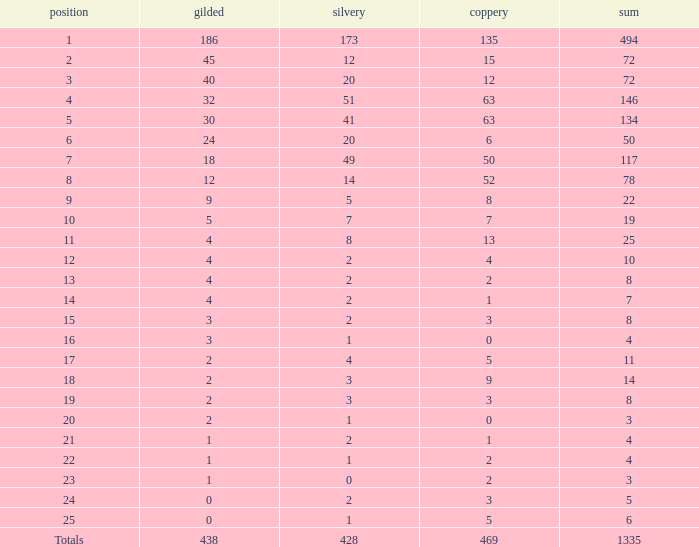What is the total amount of gold medals when there were more than 20 silvers and there were 135 bronze medals? 1.0. 